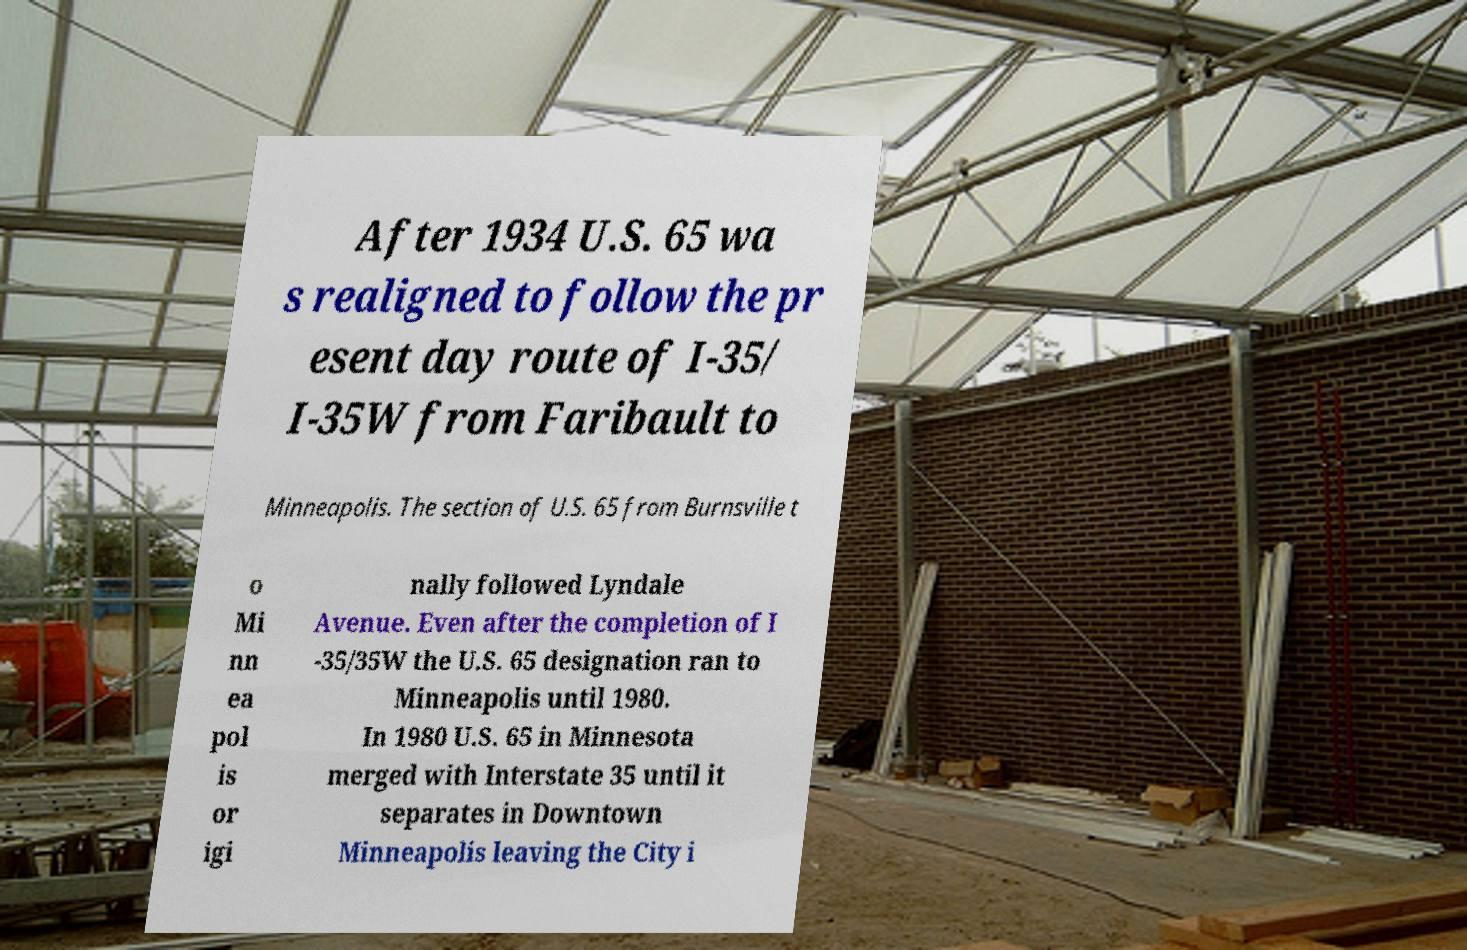Can you read and provide the text displayed in the image?This photo seems to have some interesting text. Can you extract and type it out for me? After 1934 U.S. 65 wa s realigned to follow the pr esent day route of I-35/ I-35W from Faribault to Minneapolis. The section of U.S. 65 from Burnsville t o Mi nn ea pol is or igi nally followed Lyndale Avenue. Even after the completion of I -35/35W the U.S. 65 designation ran to Minneapolis until 1980. In 1980 U.S. 65 in Minnesota merged with Interstate 35 until it separates in Downtown Minneapolis leaving the City i 